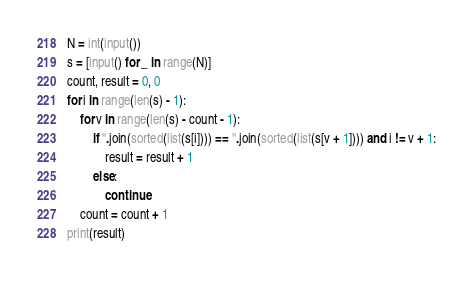Convert code to text. <code><loc_0><loc_0><loc_500><loc_500><_Python_>N = int(input())
s = [input() for _ in range(N)]
count, result = 0, 0
for i in range(len(s) - 1):
    for v in range(len(s) - count - 1):
        if ''.join(sorted(list(s[i]))) == ''.join(sorted(list(s[v + 1]))) and i != v + 1:
            result = result + 1
        else:
            continue
    count = count + 1
print(result)</code> 